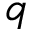<formula> <loc_0><loc_0><loc_500><loc_500>q</formula> 